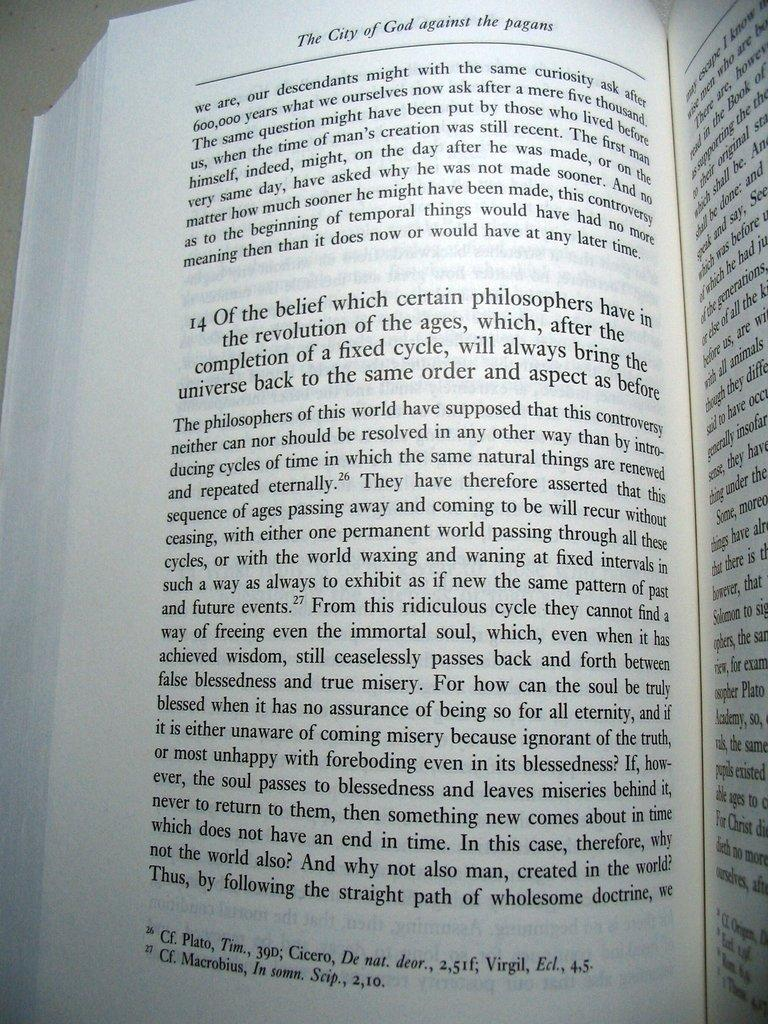Provide a one-sentence caption for the provided image. A book open to a page and at the top it says the city of god against the pagans. 